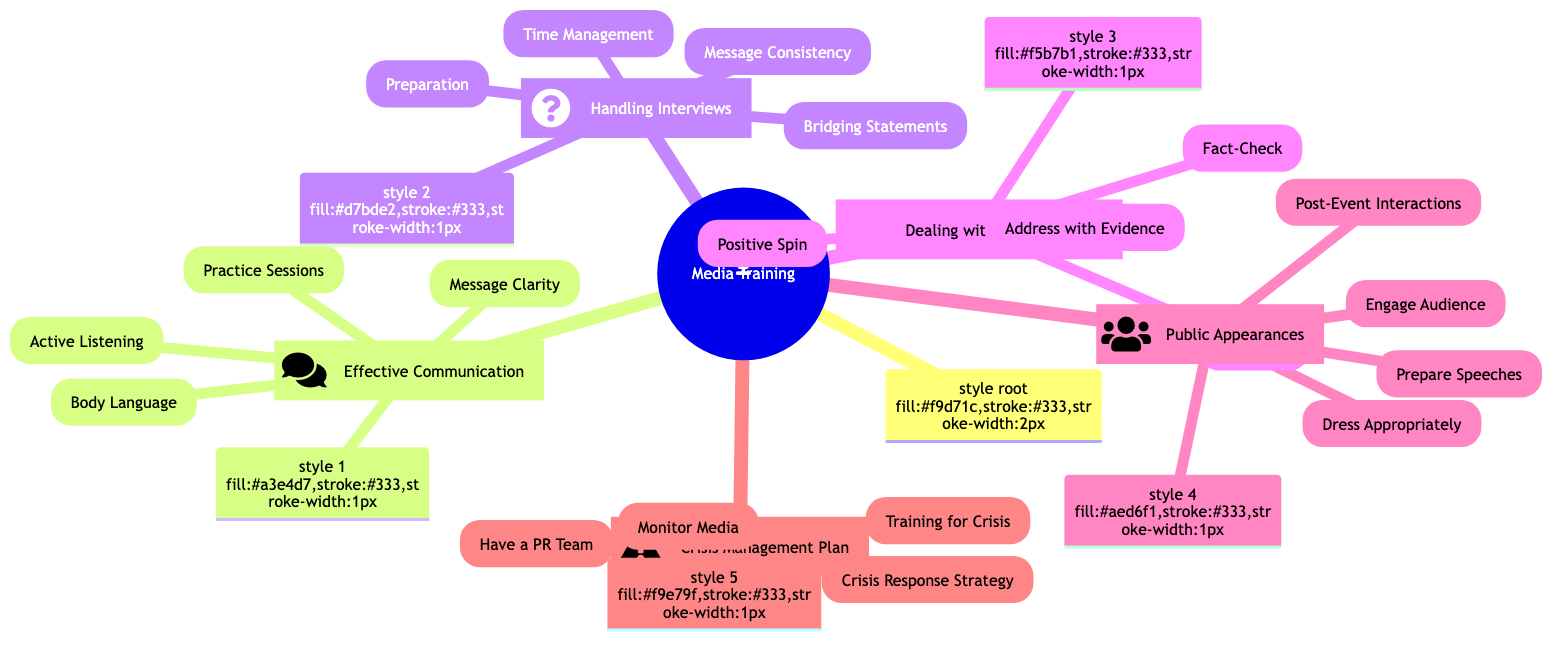What are the four main categories in the diagram? The diagram's main categories are listed as branches, which are "Effective Communication Techniques," "Handling Interviews," "Dealing with Negative Press," "Public Appearances," and "Crisis Management Plan."
Answer: Effective Communication Techniques, Handling Interviews, Dealing with Negative Press, Public Appearances, Crisis Management Plan How many techniques are under "Dealing with Negative Press"? The branch "Dealing with Negative Press" has four techniques listed: "Stay Calm," "Fact-Check," "Address with Evidence," and "Positive Spin."
Answer: Four What is one technique for "Effective Communication Techniques"? Under "Effective Communication Techniques," there are four techniques listed, one of which is "Message Clarity."
Answer: Message Clarity What relationship exists between "Handling Interviews" and "Message Consistency"? "Message Consistency" is a technique found under "Handling Interviews," indicating that it is a component of how to effectively handle interviews.
Answer: Component What is the purpose of having a PR team according to the diagram? The diagram states that having a PR team is necessary for crisis management as mentioned in the "Crisis Management Plan" category, indicating it supports effective crisis response.
Answer: Crisis management How many sub-techniques are under "Public Appearances"? The "Public Appearances" category includes four sub-techniques: "Dress Appropriately," "Engage Audience," "Prepare Speeches," and "Post-Event Interactions."
Answer: Four What is a recommended action during a crisis as per the diagram? The diagram suggests undergoing "Training for Crisis" as part of the "Crisis Management Plan," indicating ongoing preparedness for managing crises effectively.
Answer: Training for Crisis Which section contains the technique "Bridging Statements"? "Bridging Statements" is located under the "Handling Interviews" section, which focuses on managing interview scenarios.
Answer: Handling Interviews What is a strategy for "Dealing with Negative Press"? One strategy listed under "Dealing with Negative Press" is "Address with Evidence," which suggests providing factual information to counteract negative claims.
Answer: Address with Evidence 